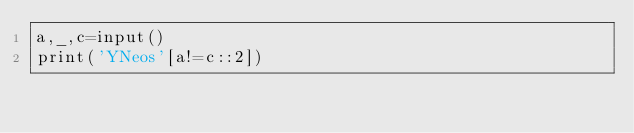Convert code to text. <code><loc_0><loc_0><loc_500><loc_500><_Cython_>a,_,c=input()
print('YNeos'[a!=c::2])</code> 